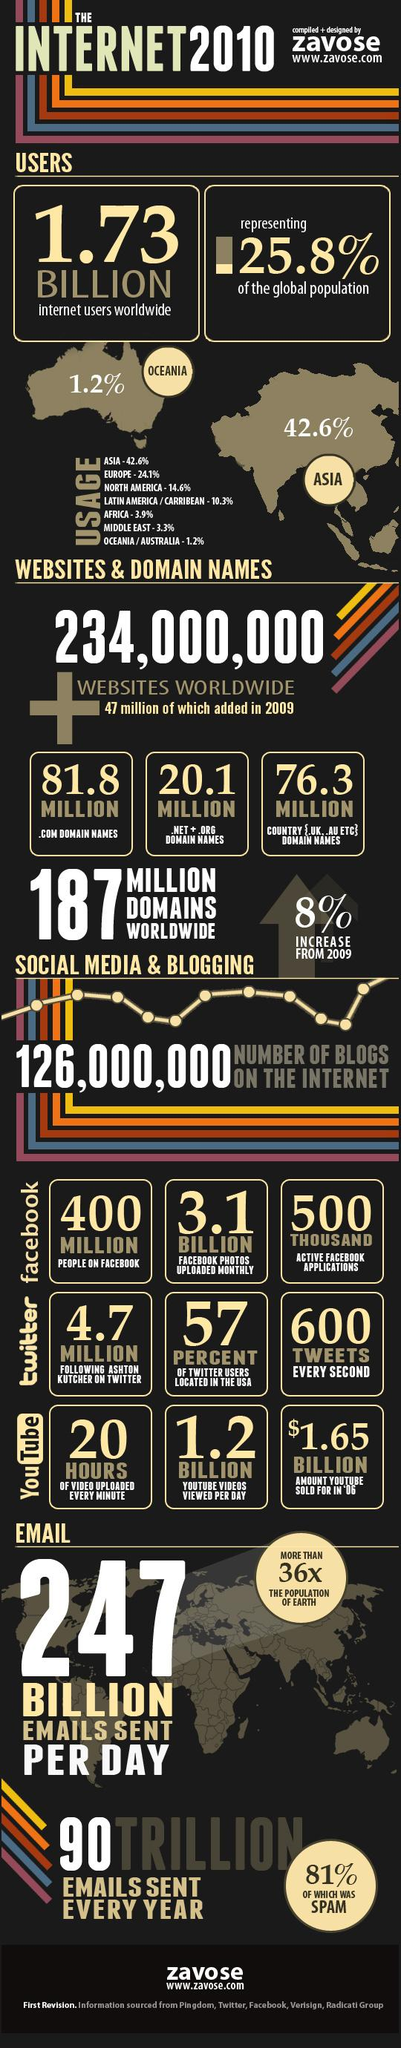Outline some significant characteristics in this image. In 2009, a total of 178.2 million domain names were added across all .com, .net, and .org categories, as well as the country categories. The percentage difference of internet users in Asia and Oceania is 41.4%. 